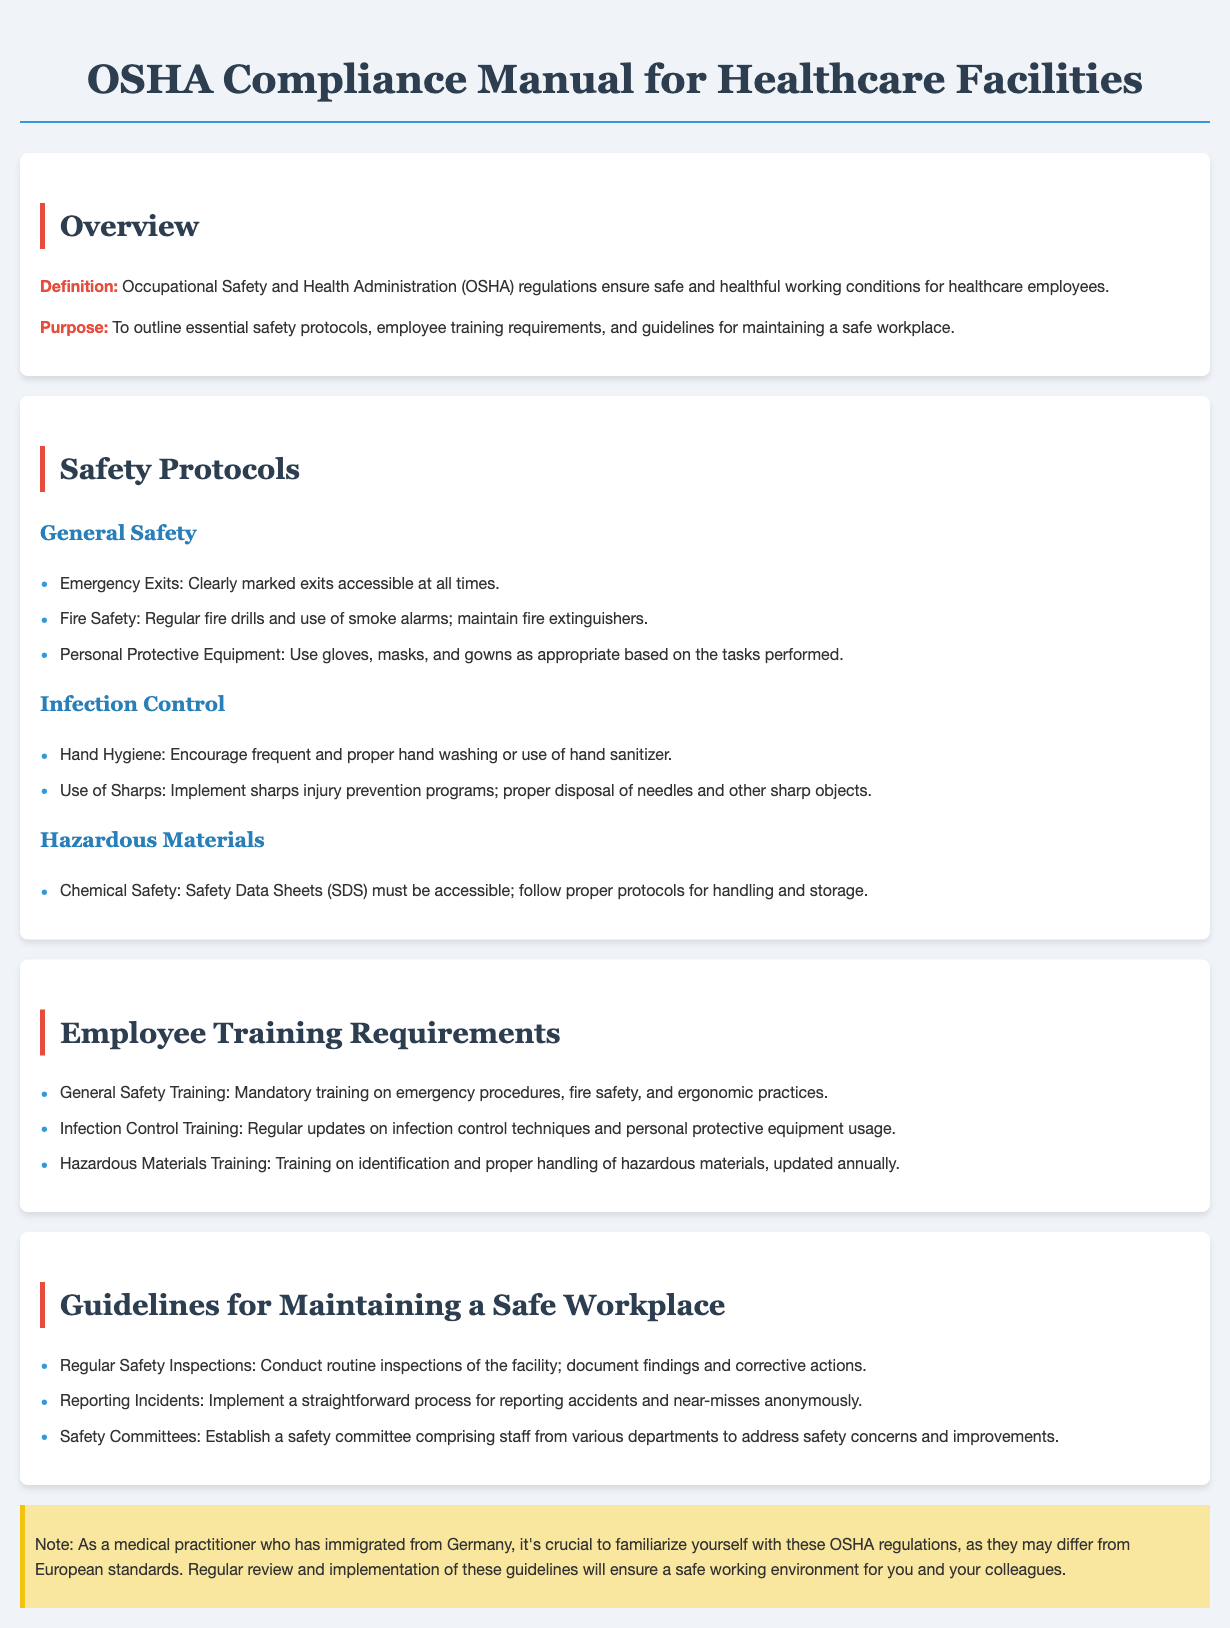What is the purpose of the OSHA Compliance Manual? The purpose is to outline essential safety protocols, employee training requirements, and guidelines for maintaining a safe workplace.
Answer: To outline essential safety protocols, employee training requirements, and guidelines for maintaining a safe workplace What type of training is required for hazardous materials? The document states that training on identification and proper handling of hazardous materials is updated annually.
Answer: Updated annually What should be included in infection control training? Regular updates on infection control techniques and personal protective equipment usage are required.
Answer: Infection control techniques and personal protective equipment usage How often should safety inspections be conducted? The document mentions conducting routine inspections of the facility, but does not specify a frequency.
Answer: Regularly What is a requirement for personal protective equipment? Personal protective equipment must be used as appropriate based on the tasks performed.
Answer: As appropriate based on the tasks performed What is a focus of the safety committee? The safety committee should address safety concerns and improvements in the facility.
Answer: Safety concerns and improvements What document oversees safety and health regulations? The occupational safety and health administration oversees safety and health regulations.
Answer: Occupational Safety and Health Administration (OSHA) What is emphasized in hand hygiene protocols? Encouraging frequent and proper hand washing or use of hand sanitizer is emphasized.
Answer: Frequent and proper hand washing or use of hand sanitizer 